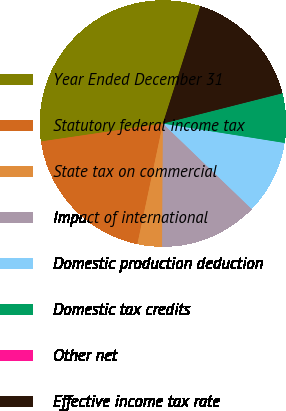<chart> <loc_0><loc_0><loc_500><loc_500><pie_chart><fcel>Year Ended December 31<fcel>Statutory federal income tax<fcel>State tax on commercial<fcel>Impact of international<fcel>Domestic production deduction<fcel>Domestic tax credits<fcel>Other net<fcel>Effective income tax rate<nl><fcel>32.25%<fcel>19.35%<fcel>3.23%<fcel>12.9%<fcel>9.68%<fcel>6.46%<fcel>0.01%<fcel>16.13%<nl></chart> 